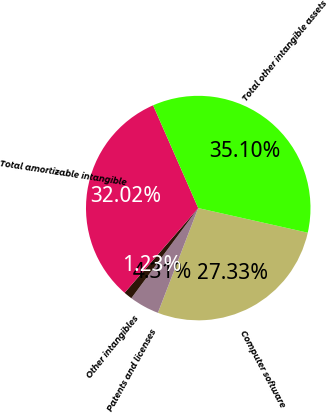Convert chart. <chart><loc_0><loc_0><loc_500><loc_500><pie_chart><fcel>Computer software<fcel>Patents and licenses<fcel>Other intangibles<fcel>Total amortizable intangible<fcel>Total other intangible assets<nl><fcel>27.33%<fcel>4.31%<fcel>1.23%<fcel>32.02%<fcel>35.1%<nl></chart> 